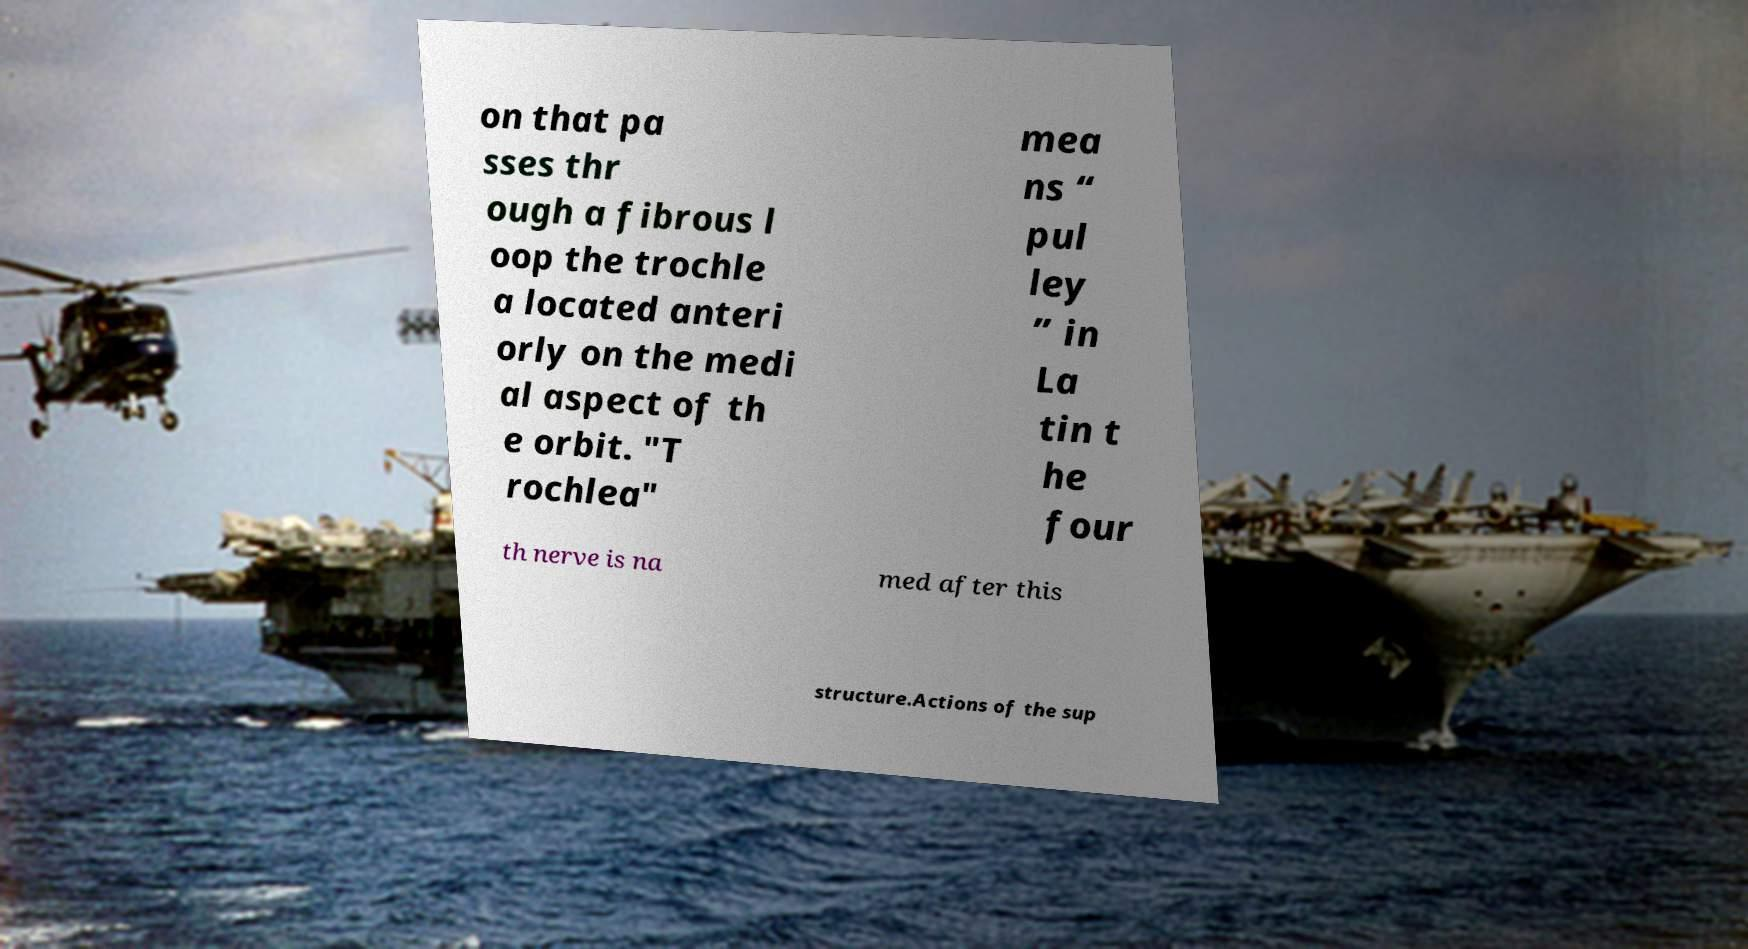Please read and relay the text visible in this image. What does it say? on that pa sses thr ough a fibrous l oop the trochle a located anteri orly on the medi al aspect of th e orbit. "T rochlea" mea ns “ pul ley ” in La tin t he four th nerve is na med after this structure.Actions of the sup 